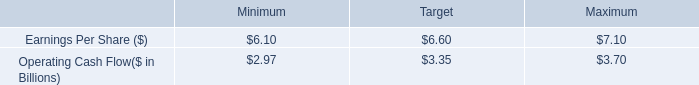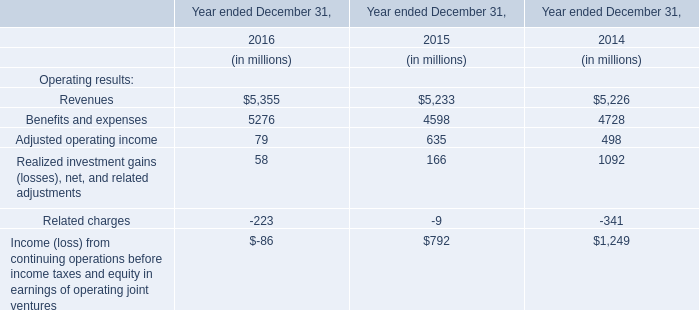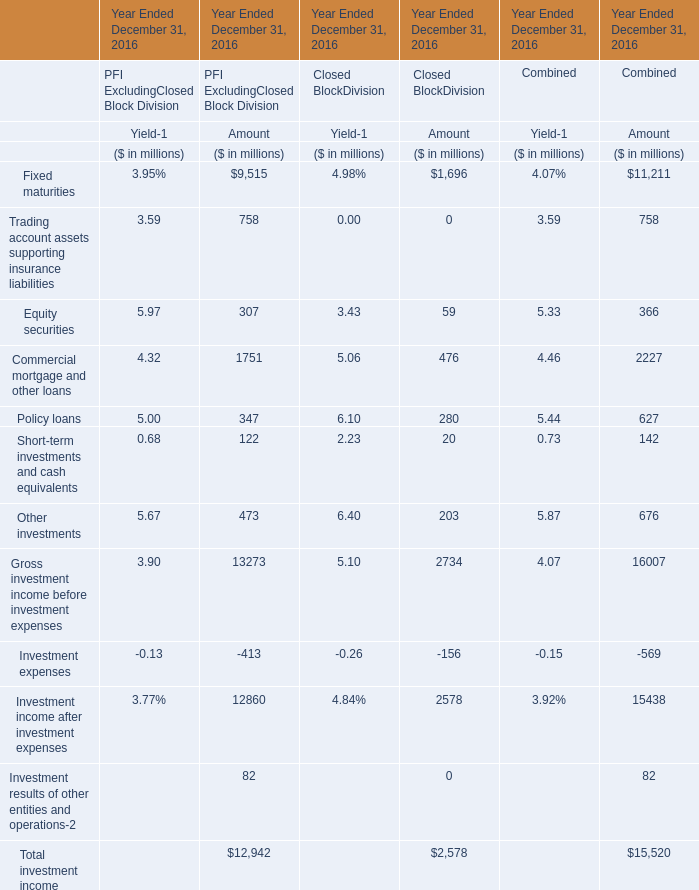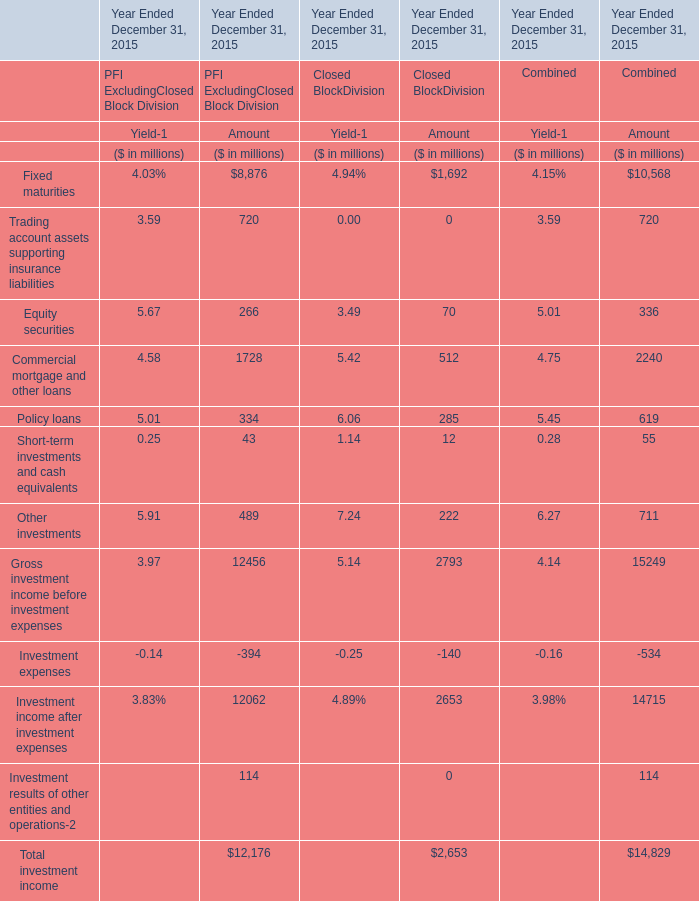What's the 18% of total elements for Closed BlockDivision of Amout ? (in million) 
Computations: (2578 * 0.18)
Answer: 464.04. 